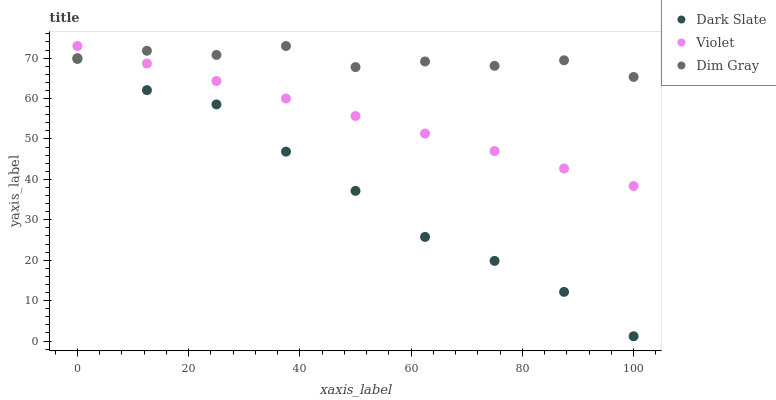Does Dark Slate have the minimum area under the curve?
Answer yes or no. Yes. Does Dim Gray have the maximum area under the curve?
Answer yes or no. Yes. Does Violet have the minimum area under the curve?
Answer yes or no. No. Does Violet have the maximum area under the curve?
Answer yes or no. No. Is Violet the smoothest?
Answer yes or no. Yes. Is Dim Gray the roughest?
Answer yes or no. Yes. Is Dim Gray the smoothest?
Answer yes or no. No. Is Violet the roughest?
Answer yes or no. No. Does Dark Slate have the lowest value?
Answer yes or no. Yes. Does Violet have the lowest value?
Answer yes or no. No. Does Violet have the highest value?
Answer yes or no. Yes. Is Dark Slate less than Violet?
Answer yes or no. Yes. Is Violet greater than Dark Slate?
Answer yes or no. Yes. Does Dim Gray intersect Violet?
Answer yes or no. Yes. Is Dim Gray less than Violet?
Answer yes or no. No. Is Dim Gray greater than Violet?
Answer yes or no. No. Does Dark Slate intersect Violet?
Answer yes or no. No. 